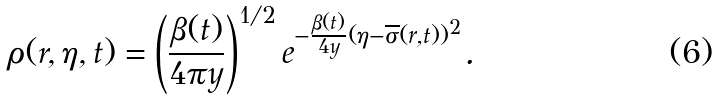Convert formula to latex. <formula><loc_0><loc_0><loc_500><loc_500>\rho ( { r } , \eta , t ) = \left ( \frac { \beta ( t ) } { 4 \pi y } \right ) ^ { 1 / 2 } e ^ { - \frac { \beta ( t ) } { 4 y } ( \eta - \overline { \sigma } ( { r } , t ) ) ^ { 2 } } .</formula> 